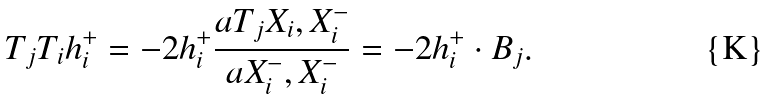Convert formula to latex. <formula><loc_0><loc_0><loc_500><loc_500>T _ { j } T _ { i } h _ { i } ^ { + } = - 2 h _ { i } ^ { + } \frac { a { T _ { j } X _ { i } , X _ { i } ^ { - } } } { a { X _ { i } ^ { - } , X _ { i } ^ { - } } } = - 2 h _ { i } ^ { + } \cdot B _ { j } .</formula> 